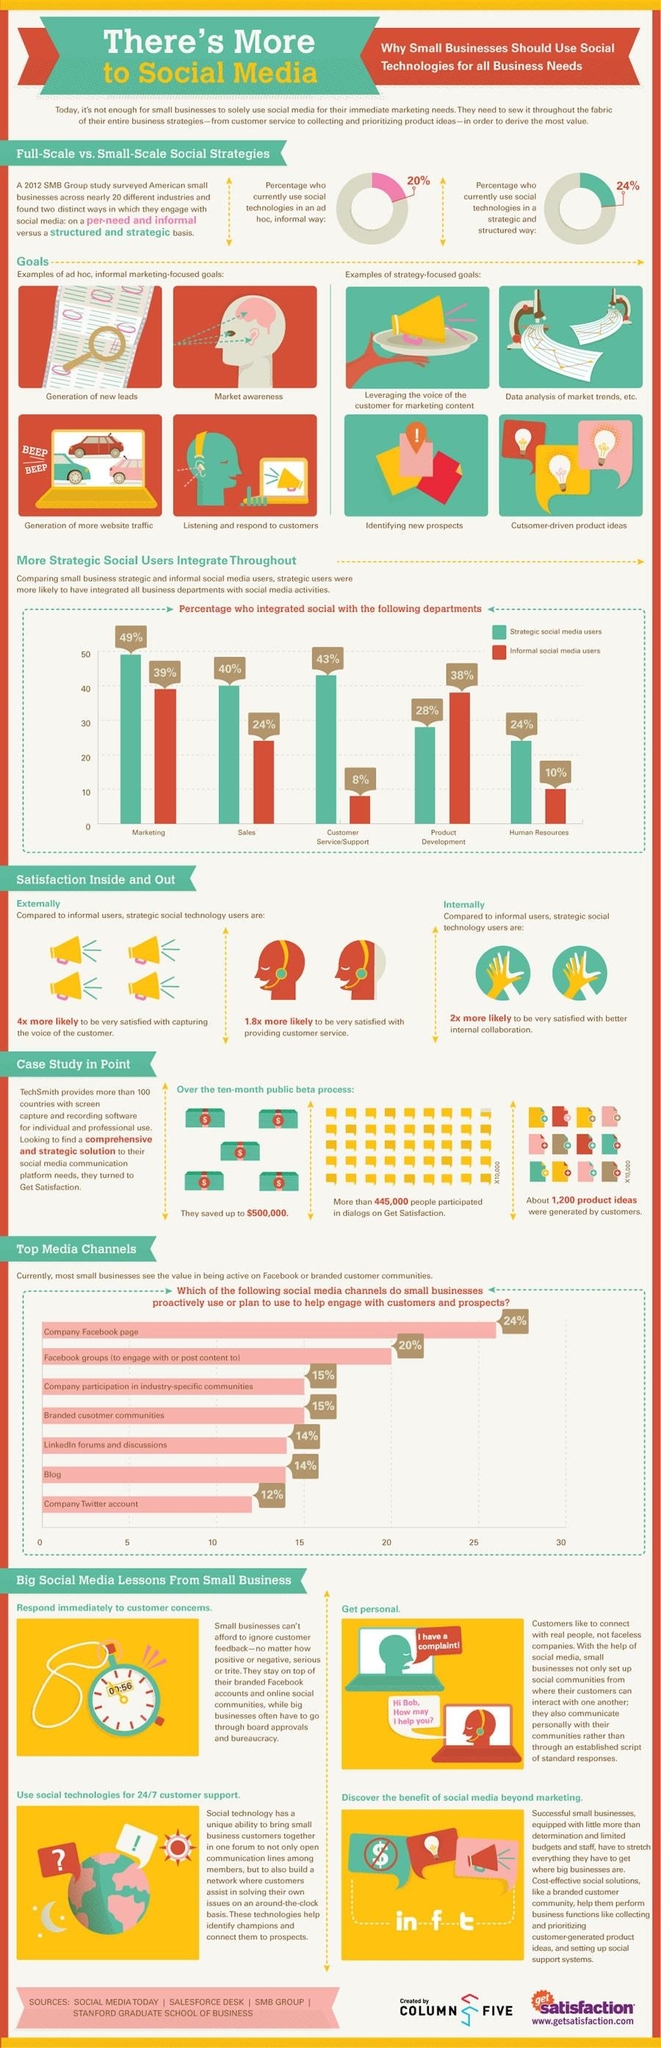Outline some significant characteristics in this image. According to the data, a significant portion of small businesses, which is 38%, rely on the company's Facebook page and blog to interact with customers and prospects. According to a recent study, 80% of people are not using social technologies in an ad-hoc and informal way. According to the given data, approximately 36% of small businesses utilize Facebook and Twitter accounts to engage with customers and prospects. Approximately 66% of strategic and informal social media users are involved in product development. There are four strategy-focused goals mentioned in this infographic. 